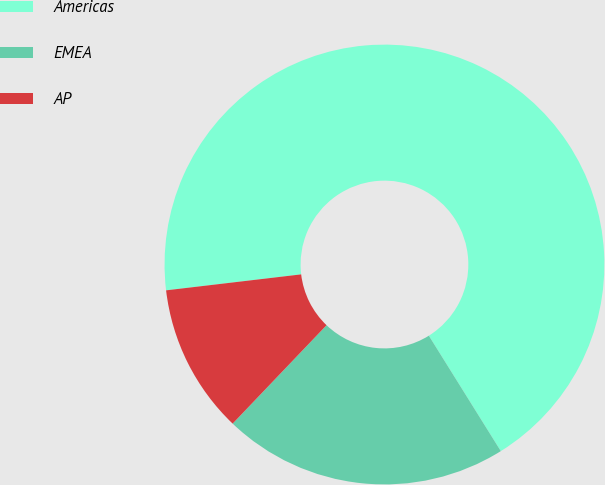Convert chart to OTSL. <chart><loc_0><loc_0><loc_500><loc_500><pie_chart><fcel>Americas<fcel>EMEA<fcel>AP<nl><fcel>68.0%<fcel>21.0%<fcel>11.0%<nl></chart> 